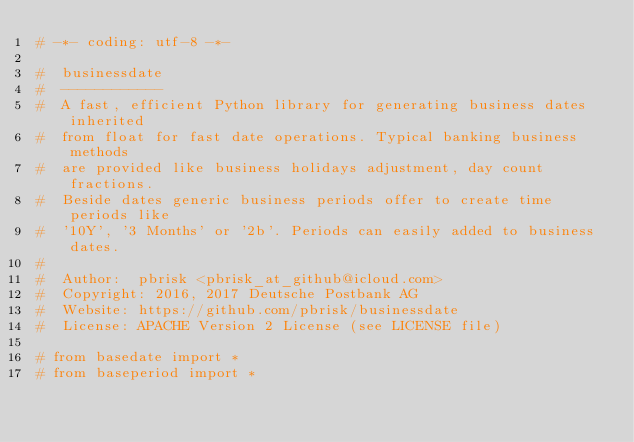Convert code to text. <code><loc_0><loc_0><loc_500><loc_500><_Python_># -*- coding: utf-8 -*-

#  businessdate
#  ------------
#  A fast, efficient Python library for generating business dates inherited
#  from float for fast date operations. Typical banking business methods
#  are provided like business holidays adjustment, day count fractions.
#  Beside dates generic business periods offer to create time periods like
#  '10Y', '3 Months' or '2b'. Periods can easily added to business dates.
#
#  Author:  pbrisk <pbrisk_at_github@icloud.com>
#  Copyright: 2016, 2017 Deutsche Postbank AG
#  Website: https://github.com/pbrisk/businessdate
#  License: APACHE Version 2 License (see LICENSE file)

# from basedate import *
# from baseperiod import *</code> 